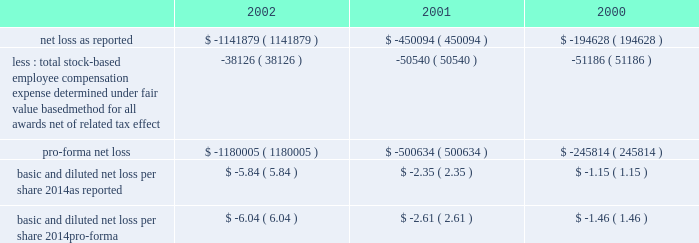American tower corporation and subsidiaries notes to consolidated financial statements 2014 ( continued ) the table illustrates the effect on net loss and net loss per share if the company had applied the fair value recognition provisions of sfas no .
123 to stock-based compensation .
The estimated fair value of each option is calculated using the black-scholes option-pricing model ( in thousands , except per share amounts ) : .
Fair value of financial instruments 2014as of december 31 , 2002 , the carrying amounts of the company 2019s 5.0% ( 5.0 % ) convertible notes , the 2.25% ( 2.25 % ) convertible notes , the 6.25% ( 6.25 % ) convertible notes and the senior notes were approximately $ 450.0 million , $ 210.9 million , $ 212.7 million and $ 1.0 billion , respectively , and the fair values of such notes were $ 291.4 million , $ 187.2 million , $ 144.4 million and $ 780.0 million , respectively .
As of december 31 , 2001 , the carrying amount of the company 2019s 5.0% ( 5.0 % ) convertible notes , the 2.25% ( 2.25 % ) convertible notes , the 6.25% ( 6.25 % ) convertible notes and the senior notes were approximately $ 450.0 million , $ 204.1 million , $ 212.8 million and $ 1.0 billion , respectively , and the fair values of such notes were $ 268.3 million , $ 173.1 million , $ 158.2 million and $ 805.0 million , respectively .
Fair values were determined based on quoted market prices .
The carrying values of all other financial instruments reasonably approximate the related fair values as of december 31 , 2002 and 2001 .
Retirement plan 2014the company has a 401 ( k ) plan covering substantially all employees who meet certain age and employment requirements .
Under the plan , the company matches 35% ( 35 % ) of participants 2019 contributions up to a maximum 5% ( 5 % ) of a participant 2019s compensation .
The company contributed approximately $ 979000 , $ 1540000 and $ 1593000 to the plan for the years ended december 31 , 2002 , 2001 and 2000 , respectively .
Recent accounting pronouncements 2014in june 2001 , the fasb issued sfas no .
143 , 201caccounting for asset retirement obligations . 201d this statement establishes accounting standards for the recognition and measurement of liabilities associated with the retirement of tangible long-lived assets and the related asset retirement costs .
The requirements of sfas no .
143 are effective for the company as of january 1 , 2003 .
The company will adopt this statement in the first quarter of 2003 and does not expect the impact of adopting this statement to have a material impact on its consolidated financial position or results of operations .
In august 2001 , the fasb issued sfas no .
144 , 201caccounting for the impairment or disposal of long-lived assets . 201d sfas no .
144 supersedes sfas no .
121 , 201caccounting for the impairment of long-lived assets and for long-lived assets to be disposed of , 201d but retains many of its fundamental provisions .
Sfas no .
144 also clarifies certain measurement and classification issues from sfas no .
121 .
In addition , sfas no .
144 supersedes the accounting and reporting provisions for the disposal of a business segment as found in apb no .
30 , 201creporting the results of operations 2014reporting the effects of disposal of a segment of a business and extraordinary , unusual and infrequently occurring events and transactions 201d .
However , sfas no .
144 retains the requirement in apb no .
30 to separately report discontinued operations , and broadens the scope of such requirement to include more types of disposal transactions .
The scope of sfas no .
144 excludes goodwill and other intangible assets that are not to be amortized , as the accounting for such items is prescribed by sfas no .
142 .
The company implemented sfas no .
144 on january 1 , 2002 .
Accordingly , all relevant impairment assessments and decisions concerning discontinued operations have been made under this standard in 2002. .
What is the percentage change in 401 ( k ) contributions from 2000 to 2001? 
Computations: ((1540000 - 1593000) / 1593000)
Answer: -0.03327. 